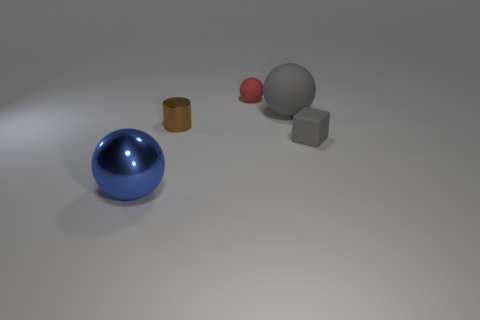Add 1 small brown metal blocks. How many objects exist? 6 Subtract all gray rubber spheres. How many spheres are left? 2 Subtract all blue balls. How many balls are left? 2 Add 5 gray cubes. How many gray cubes exist? 6 Subtract 0 green spheres. How many objects are left? 5 Subtract all cylinders. How many objects are left? 4 Subtract all purple balls. Subtract all red cubes. How many balls are left? 3 Subtract all purple cylinders. How many blue balls are left? 1 Subtract all big red blocks. Subtract all blue things. How many objects are left? 4 Add 5 gray spheres. How many gray spheres are left? 6 